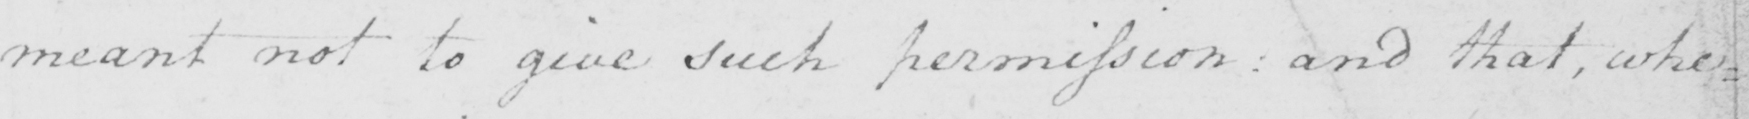Can you read and transcribe this handwriting? meant not to give such permission :  and that whe : 